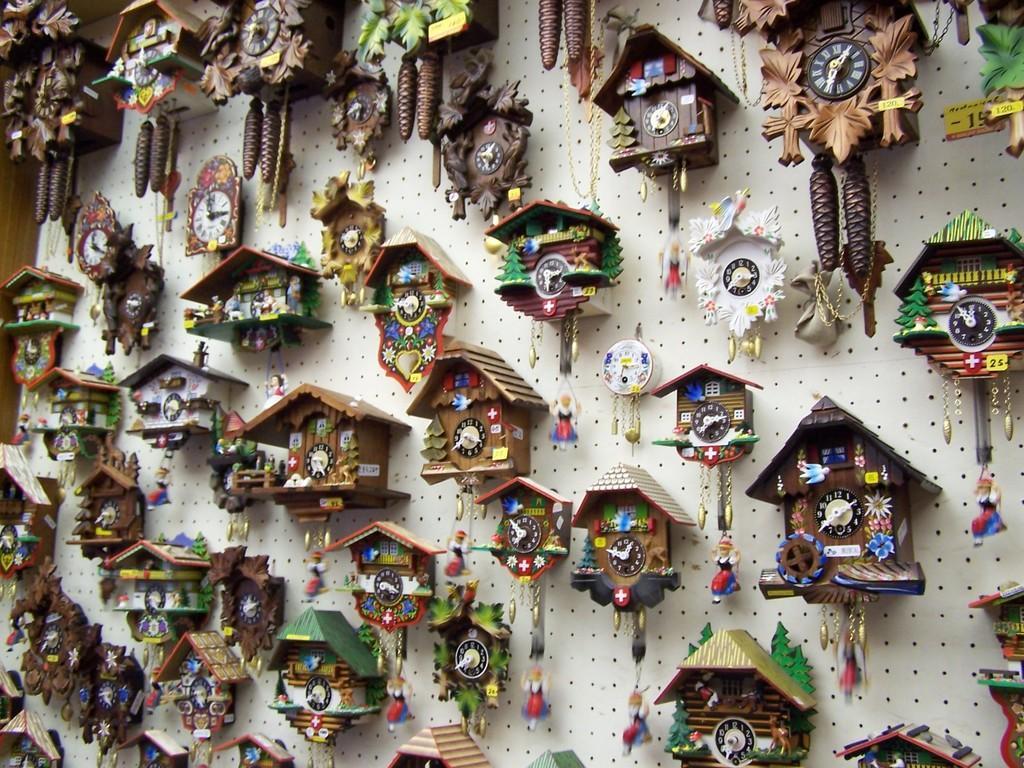Please provide a concise description of this image. In this image I can see many clocks and cuckoo clocks attached to a wall. 